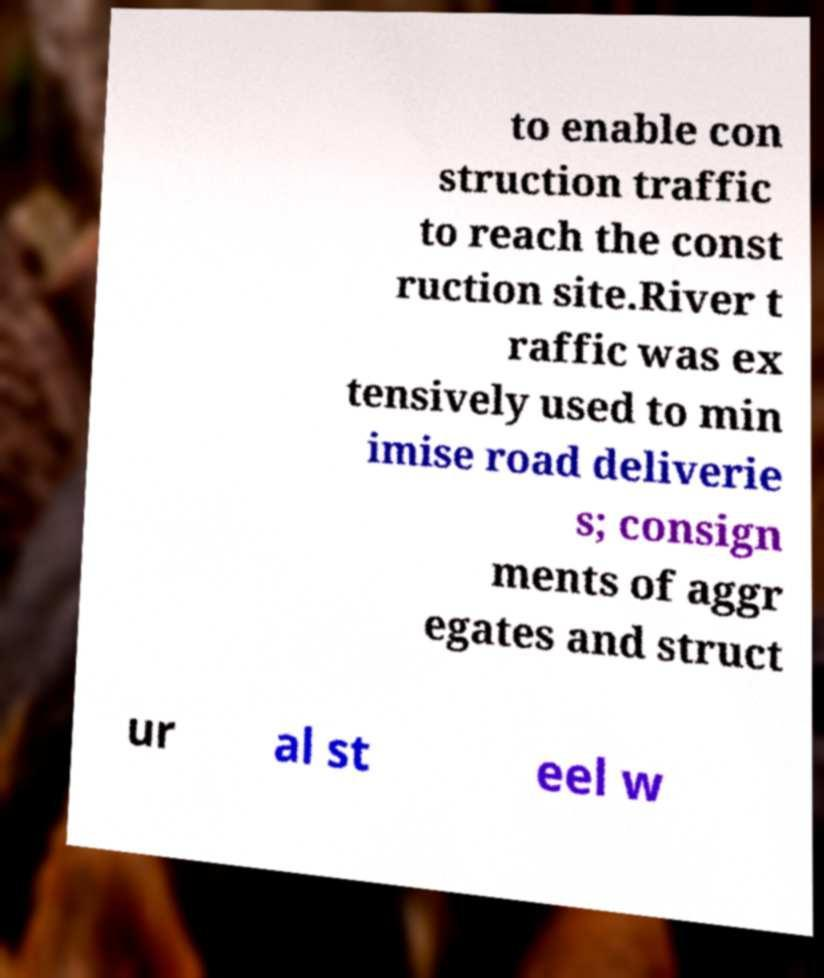Please read and relay the text visible in this image. What does it say? to enable con struction traffic to reach the const ruction site.River t raffic was ex tensively used to min imise road deliverie s; consign ments of aggr egates and struct ur al st eel w 